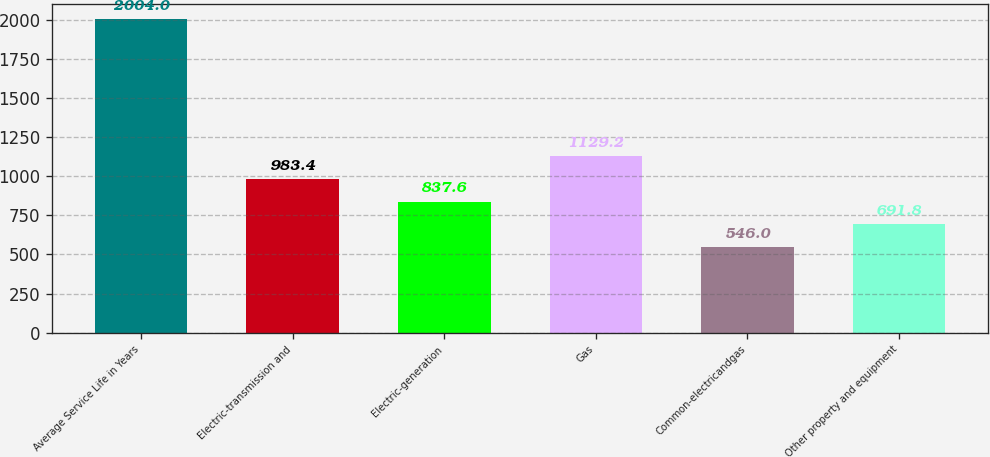Convert chart. <chart><loc_0><loc_0><loc_500><loc_500><bar_chart><fcel>Average Service Life in Years<fcel>Electric-transmission and<fcel>Electric-generation<fcel>Gas<fcel>Common-electricandgas<fcel>Other property and equipment<nl><fcel>2004<fcel>983.4<fcel>837.6<fcel>1129.2<fcel>546<fcel>691.8<nl></chart> 